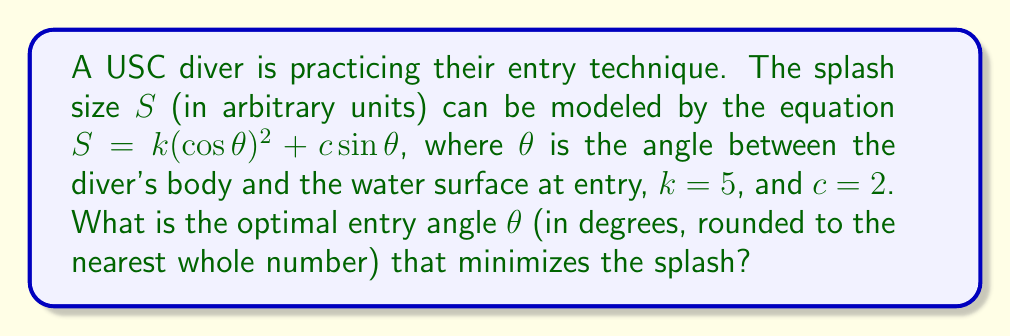Provide a solution to this math problem. To find the optimal angle that minimizes the splash, we need to follow these steps:

1) The splash size $S$ is given by the equation:
   $$S = k(\cos\theta)^2 + c\sin\theta$$
   where $k = 5$ and $c = 2$

2) To find the minimum, we need to differentiate $S$ with respect to $\theta$ and set it to zero:
   $$\frac{dS}{d\theta} = -2k\cos\theta\sin\theta + c\cos\theta = 0$$

3) Substituting the values:
   $$-10\cos\theta\sin\theta + 2\cos\theta = 0$$

4) Factor out $\cos\theta$:
   $$\cos\theta(-10\sin\theta + 2) = 0$$

5) This equation is satisfied when either $\cos\theta = 0$ or $-10\sin\theta + 2 = 0$

6) $\cos\theta = 0$ when $\theta = 90°$, but this would result in a belly flop, so we consider the other case:
   $$-10\sin\theta + 2 = 0$$
   $$10\sin\theta = 2$$
   $$\sin\theta = 0.2$$

7) Taking the inverse sine (arcsin):
   $$\theta = \arcsin(0.2) \approx 11.5°$$

8) Rounding to the nearest whole number:
   $$\theta \approx 12°$$

To confirm this is a minimum (not a maximum), we could check the second derivative is positive at this point.
Answer: 12° 